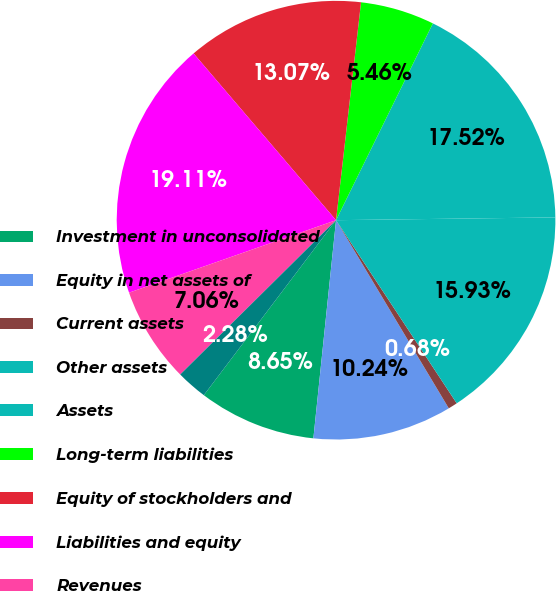Convert chart to OTSL. <chart><loc_0><loc_0><loc_500><loc_500><pie_chart><fcel>Investment in unconsolidated<fcel>Equity in net assets of<fcel>Current assets<fcel>Other assets<fcel>Assets<fcel>Long-term liabilities<fcel>Equity of stockholders and<fcel>Liabilities and equity<fcel>Revenues<fcel>Expenses<nl><fcel>8.65%<fcel>10.24%<fcel>0.68%<fcel>15.93%<fcel>17.52%<fcel>5.46%<fcel>13.07%<fcel>19.11%<fcel>7.06%<fcel>2.28%<nl></chart> 